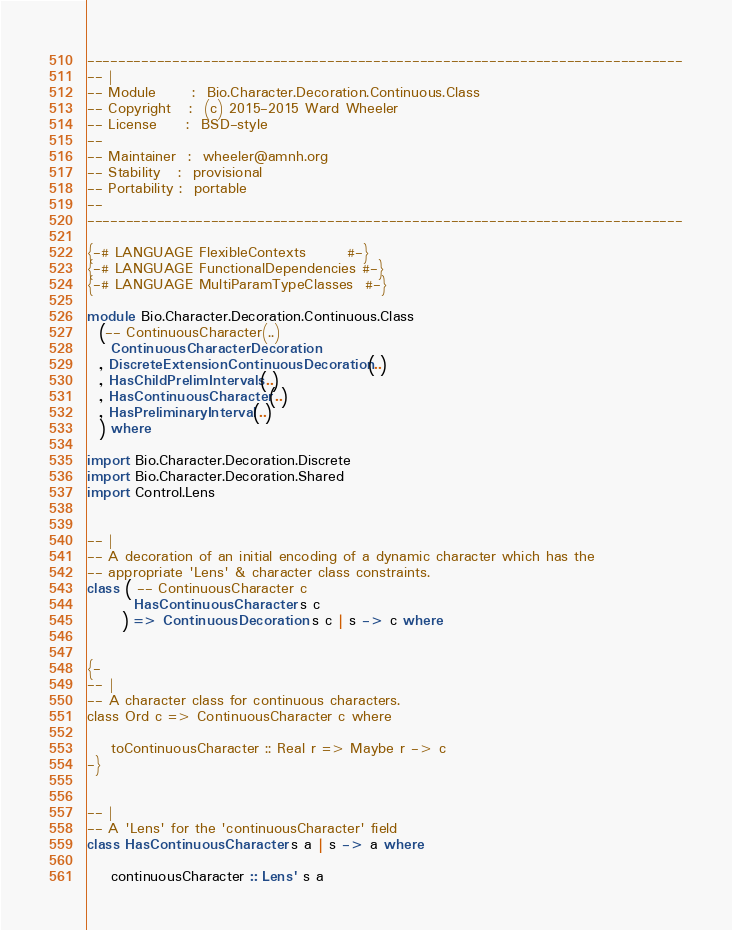Convert code to text. <code><loc_0><loc_0><loc_500><loc_500><_Haskell_>-----------------------------------------------------------------------------
-- |
-- Module      :  Bio.Character.Decoration.Continuous.Class
-- Copyright   :  (c) 2015-2015 Ward Wheeler
-- License     :  BSD-style
--
-- Maintainer  :  wheeler@amnh.org
-- Stability   :  provisional
-- Portability :  portable
--
-----------------------------------------------------------------------------

{-# LANGUAGE FlexibleContexts       #-}
{-# LANGUAGE FunctionalDependencies #-}
{-# LANGUAGE MultiParamTypeClasses  #-}

module Bio.Character.Decoration.Continuous.Class
  (-- ContinuousCharacter(..)
    ContinuousCharacterDecoration
  , DiscreteExtensionContinuousDecoration(..)
  , HasChildPrelimIntervals(..)
  , HasContinuousCharacter(..)
  , HasPreliminaryInterval(..)
  ) where

import Bio.Character.Decoration.Discrete
import Bio.Character.Decoration.Shared
import Control.Lens


-- |
-- A decoration of an initial encoding of a dynamic character which has the
-- appropriate 'Lens' & character class constraints.
class ( -- ContinuousCharacter c
        HasContinuousCharacter s c
      ) => ContinuousDecoration s c | s -> c where


{-
-- |
-- A character class for continuous characters.
class Ord c => ContinuousCharacter c where

    toContinuousCharacter :: Real r => Maybe r -> c
-}


-- |
-- A 'Lens' for the 'continuousCharacter' field
class HasContinuousCharacter s a | s -> a where

    continuousCharacter :: Lens' s a</code> 